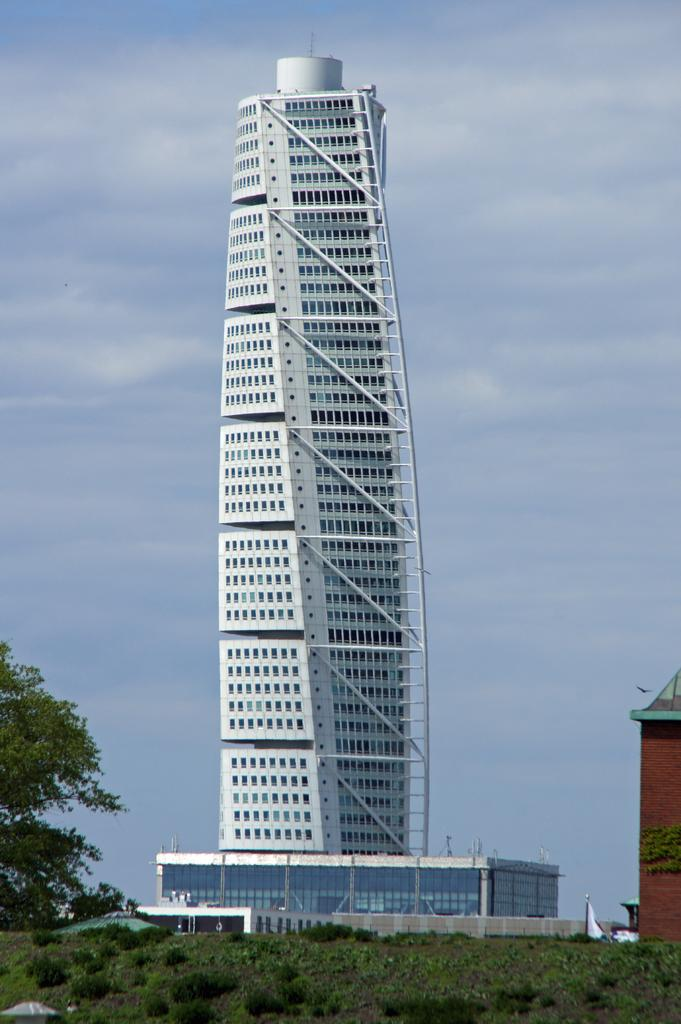What type of vegetation can be seen in the image? There is grass and plants in the image. What type of structure is present in the image? There is a tower building in the image. What is attached to the tower building? There is a flag in the image. What can be seen in the background of the image? There are trees and the sky visible in the background of the image. What is the condition of the sky in the image? The sky appears to be cloudy in the image. Can you tell me the total cost of the items listed on the receipt in the image? There is no receipt present in the image. What type of health advice is being given by the carpenter in the image? There is no carpenter or health advice present in the image. 